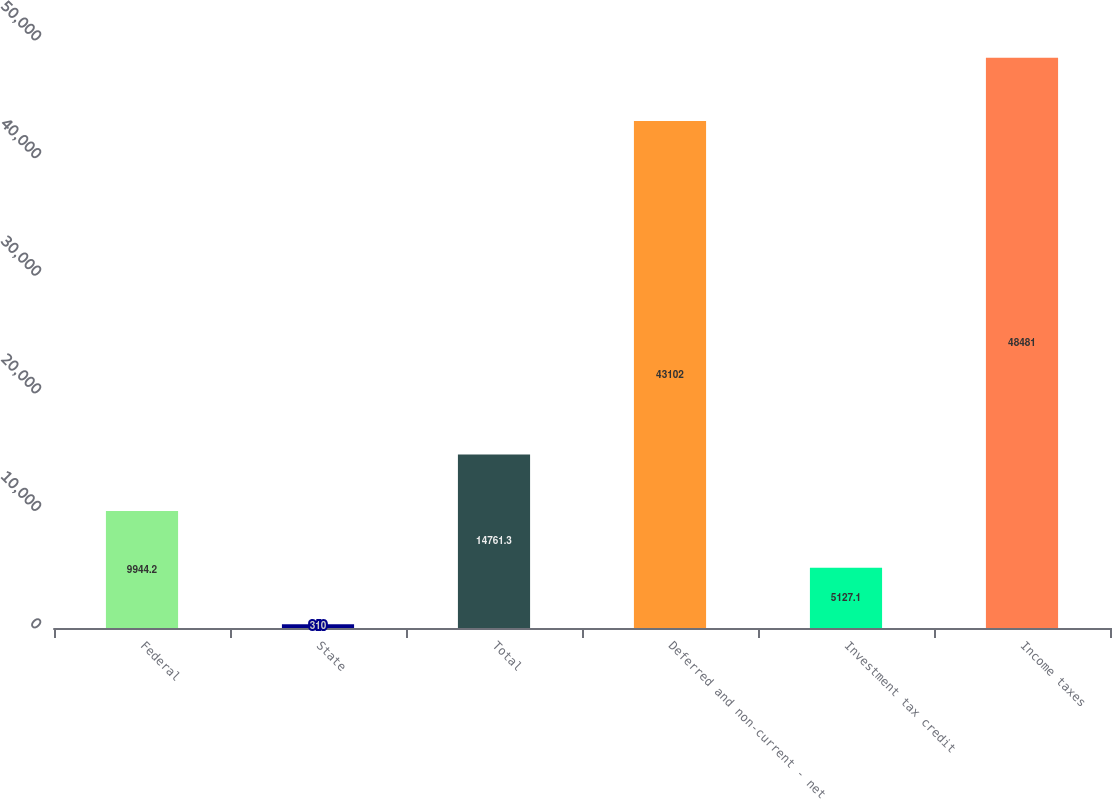Convert chart. <chart><loc_0><loc_0><loc_500><loc_500><bar_chart><fcel>Federal<fcel>State<fcel>Total<fcel>Deferred and non-current - net<fcel>Investment tax credit<fcel>Income taxes<nl><fcel>9944.2<fcel>310<fcel>14761.3<fcel>43102<fcel>5127.1<fcel>48481<nl></chart> 